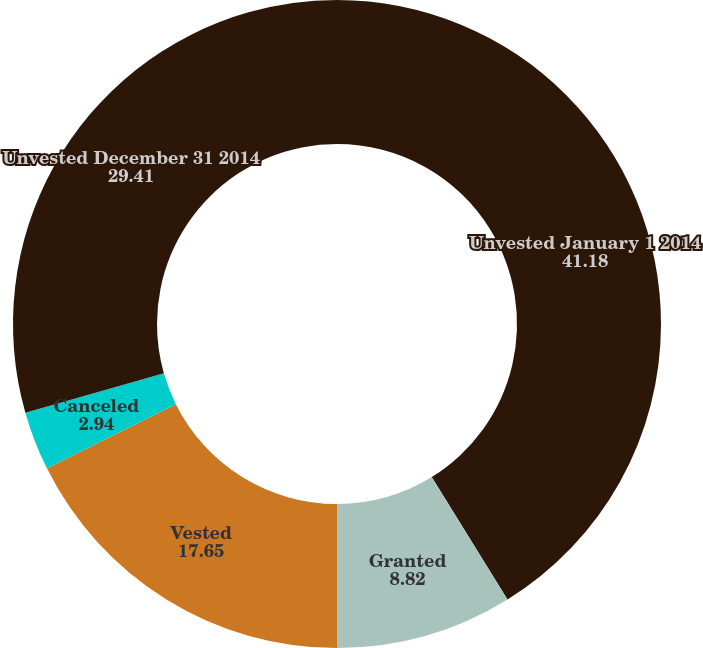Convert chart. <chart><loc_0><loc_0><loc_500><loc_500><pie_chart><fcel>Unvested January 1 2014<fcel>Granted<fcel>Vested<fcel>Canceled<fcel>Unvested December 31 2014<nl><fcel>41.18%<fcel>8.82%<fcel>17.65%<fcel>2.94%<fcel>29.41%<nl></chart> 